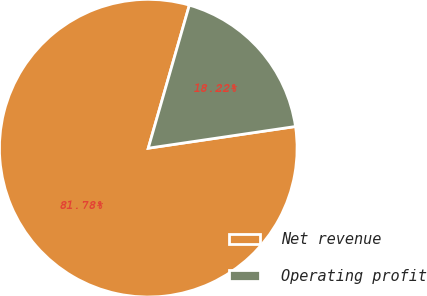Convert chart. <chart><loc_0><loc_0><loc_500><loc_500><pie_chart><fcel>Net revenue<fcel>Operating profit<nl><fcel>81.78%<fcel>18.22%<nl></chart> 